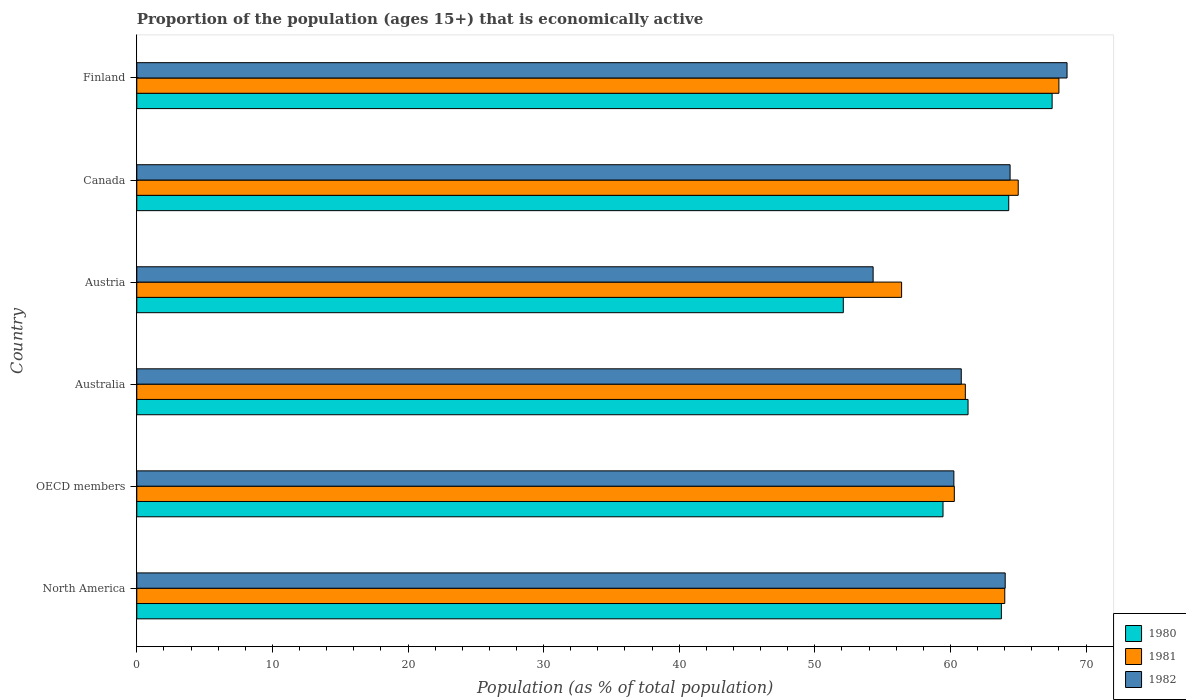How many bars are there on the 5th tick from the top?
Your answer should be compact. 3. What is the label of the 2nd group of bars from the top?
Provide a short and direct response. Canada. What is the proportion of the population that is economically active in 1982 in Canada?
Your response must be concise. 64.4. Across all countries, what is the maximum proportion of the population that is economically active in 1980?
Provide a succinct answer. 67.5. Across all countries, what is the minimum proportion of the population that is economically active in 1982?
Make the answer very short. 54.3. In which country was the proportion of the population that is economically active in 1982 maximum?
Provide a short and direct response. Finland. In which country was the proportion of the population that is economically active in 1980 minimum?
Offer a terse response. Austria. What is the total proportion of the population that is economically active in 1981 in the graph?
Make the answer very short. 374.79. What is the difference between the proportion of the population that is economically active in 1981 in Australia and that in Austria?
Offer a very short reply. 4.7. What is the difference between the proportion of the population that is economically active in 1980 in North America and the proportion of the population that is economically active in 1981 in OECD members?
Your response must be concise. 3.47. What is the average proportion of the population that is economically active in 1980 per country?
Your answer should be very brief. 61.4. What is the difference between the proportion of the population that is economically active in 1981 and proportion of the population that is economically active in 1982 in Canada?
Provide a short and direct response. 0.6. What is the ratio of the proportion of the population that is economically active in 1982 in Australia to that in Austria?
Provide a short and direct response. 1.12. Is the proportion of the population that is economically active in 1982 in Finland less than that in North America?
Ensure brevity in your answer.  No. Is the difference between the proportion of the population that is economically active in 1981 in Canada and Finland greater than the difference between the proportion of the population that is economically active in 1982 in Canada and Finland?
Your response must be concise. Yes. What is the difference between the highest and the second highest proportion of the population that is economically active in 1982?
Keep it short and to the point. 4.2. What is the difference between the highest and the lowest proportion of the population that is economically active in 1980?
Keep it short and to the point. 15.4. In how many countries, is the proportion of the population that is economically active in 1980 greater than the average proportion of the population that is economically active in 1980 taken over all countries?
Ensure brevity in your answer.  3. Is the sum of the proportion of the population that is economically active in 1981 in Australia and OECD members greater than the maximum proportion of the population that is economically active in 1980 across all countries?
Keep it short and to the point. Yes. What does the 3rd bar from the top in Australia represents?
Your answer should be compact. 1980. What does the 3rd bar from the bottom in Finland represents?
Provide a short and direct response. 1982. Is it the case that in every country, the sum of the proportion of the population that is economically active in 1982 and proportion of the population that is economically active in 1981 is greater than the proportion of the population that is economically active in 1980?
Your answer should be very brief. Yes. How many countries are there in the graph?
Keep it short and to the point. 6. What is the difference between two consecutive major ticks on the X-axis?
Your response must be concise. 10. Are the values on the major ticks of X-axis written in scientific E-notation?
Your response must be concise. No. Does the graph contain any zero values?
Ensure brevity in your answer.  No. Where does the legend appear in the graph?
Provide a succinct answer. Bottom right. What is the title of the graph?
Your answer should be compact. Proportion of the population (ages 15+) that is economically active. Does "1974" appear as one of the legend labels in the graph?
Your answer should be compact. No. What is the label or title of the X-axis?
Provide a succinct answer. Population (as % of total population). What is the Population (as % of total population) of 1980 in North America?
Your response must be concise. 63.76. What is the Population (as % of total population) in 1981 in North America?
Make the answer very short. 64.01. What is the Population (as % of total population) of 1982 in North America?
Provide a short and direct response. 64.04. What is the Population (as % of total population) of 1980 in OECD members?
Offer a very short reply. 59.45. What is the Population (as % of total population) in 1981 in OECD members?
Offer a terse response. 60.29. What is the Population (as % of total population) of 1982 in OECD members?
Ensure brevity in your answer.  60.25. What is the Population (as % of total population) of 1980 in Australia?
Keep it short and to the point. 61.3. What is the Population (as % of total population) in 1981 in Australia?
Your response must be concise. 61.1. What is the Population (as % of total population) of 1982 in Australia?
Offer a very short reply. 60.8. What is the Population (as % of total population) of 1980 in Austria?
Your answer should be compact. 52.1. What is the Population (as % of total population) of 1981 in Austria?
Give a very brief answer. 56.4. What is the Population (as % of total population) in 1982 in Austria?
Provide a succinct answer. 54.3. What is the Population (as % of total population) of 1980 in Canada?
Your answer should be compact. 64.3. What is the Population (as % of total population) of 1981 in Canada?
Your answer should be compact. 65. What is the Population (as % of total population) in 1982 in Canada?
Provide a succinct answer. 64.4. What is the Population (as % of total population) of 1980 in Finland?
Provide a short and direct response. 67.5. What is the Population (as % of total population) in 1981 in Finland?
Provide a succinct answer. 68. What is the Population (as % of total population) in 1982 in Finland?
Keep it short and to the point. 68.6. Across all countries, what is the maximum Population (as % of total population) of 1980?
Your answer should be very brief. 67.5. Across all countries, what is the maximum Population (as % of total population) of 1981?
Provide a short and direct response. 68. Across all countries, what is the maximum Population (as % of total population) of 1982?
Make the answer very short. 68.6. Across all countries, what is the minimum Population (as % of total population) of 1980?
Ensure brevity in your answer.  52.1. Across all countries, what is the minimum Population (as % of total population) in 1981?
Give a very brief answer. 56.4. Across all countries, what is the minimum Population (as % of total population) of 1982?
Ensure brevity in your answer.  54.3. What is the total Population (as % of total population) of 1980 in the graph?
Your answer should be very brief. 368.41. What is the total Population (as % of total population) in 1981 in the graph?
Give a very brief answer. 374.79. What is the total Population (as % of total population) in 1982 in the graph?
Your response must be concise. 372.39. What is the difference between the Population (as % of total population) of 1980 in North America and that in OECD members?
Provide a succinct answer. 4.3. What is the difference between the Population (as % of total population) of 1981 in North America and that in OECD members?
Your answer should be compact. 3.72. What is the difference between the Population (as % of total population) of 1982 in North America and that in OECD members?
Offer a very short reply. 3.78. What is the difference between the Population (as % of total population) of 1980 in North America and that in Australia?
Your answer should be very brief. 2.46. What is the difference between the Population (as % of total population) in 1981 in North America and that in Australia?
Your response must be concise. 2.91. What is the difference between the Population (as % of total population) of 1982 in North America and that in Australia?
Your answer should be compact. 3.24. What is the difference between the Population (as % of total population) in 1980 in North America and that in Austria?
Offer a very short reply. 11.66. What is the difference between the Population (as % of total population) of 1981 in North America and that in Austria?
Keep it short and to the point. 7.61. What is the difference between the Population (as % of total population) in 1982 in North America and that in Austria?
Offer a terse response. 9.74. What is the difference between the Population (as % of total population) of 1980 in North America and that in Canada?
Your response must be concise. -0.54. What is the difference between the Population (as % of total population) in 1981 in North America and that in Canada?
Your answer should be compact. -0.99. What is the difference between the Population (as % of total population) in 1982 in North America and that in Canada?
Your answer should be very brief. -0.36. What is the difference between the Population (as % of total population) in 1980 in North America and that in Finland?
Make the answer very short. -3.74. What is the difference between the Population (as % of total population) in 1981 in North America and that in Finland?
Your answer should be compact. -3.99. What is the difference between the Population (as % of total population) in 1982 in North America and that in Finland?
Keep it short and to the point. -4.56. What is the difference between the Population (as % of total population) of 1980 in OECD members and that in Australia?
Offer a terse response. -1.85. What is the difference between the Population (as % of total population) in 1981 in OECD members and that in Australia?
Make the answer very short. -0.81. What is the difference between the Population (as % of total population) of 1982 in OECD members and that in Australia?
Provide a succinct answer. -0.55. What is the difference between the Population (as % of total population) of 1980 in OECD members and that in Austria?
Offer a terse response. 7.35. What is the difference between the Population (as % of total population) in 1981 in OECD members and that in Austria?
Give a very brief answer. 3.89. What is the difference between the Population (as % of total population) of 1982 in OECD members and that in Austria?
Make the answer very short. 5.95. What is the difference between the Population (as % of total population) of 1980 in OECD members and that in Canada?
Offer a very short reply. -4.85. What is the difference between the Population (as % of total population) in 1981 in OECD members and that in Canada?
Give a very brief answer. -4.71. What is the difference between the Population (as % of total population) in 1982 in OECD members and that in Canada?
Provide a succinct answer. -4.15. What is the difference between the Population (as % of total population) in 1980 in OECD members and that in Finland?
Offer a very short reply. -8.05. What is the difference between the Population (as % of total population) in 1981 in OECD members and that in Finland?
Make the answer very short. -7.71. What is the difference between the Population (as % of total population) of 1982 in OECD members and that in Finland?
Provide a succinct answer. -8.35. What is the difference between the Population (as % of total population) of 1980 in Australia and that in Austria?
Provide a succinct answer. 9.2. What is the difference between the Population (as % of total population) in 1981 in Australia and that in Austria?
Offer a very short reply. 4.7. What is the difference between the Population (as % of total population) in 1982 in Australia and that in Austria?
Offer a very short reply. 6.5. What is the difference between the Population (as % of total population) in 1980 in Australia and that in Canada?
Your response must be concise. -3. What is the difference between the Population (as % of total population) in 1981 in Australia and that in Canada?
Make the answer very short. -3.9. What is the difference between the Population (as % of total population) in 1982 in Australia and that in Canada?
Your answer should be very brief. -3.6. What is the difference between the Population (as % of total population) in 1980 in Australia and that in Finland?
Keep it short and to the point. -6.2. What is the difference between the Population (as % of total population) of 1981 in Austria and that in Canada?
Your answer should be compact. -8.6. What is the difference between the Population (as % of total population) in 1982 in Austria and that in Canada?
Give a very brief answer. -10.1. What is the difference between the Population (as % of total population) of 1980 in Austria and that in Finland?
Offer a terse response. -15.4. What is the difference between the Population (as % of total population) in 1982 in Austria and that in Finland?
Give a very brief answer. -14.3. What is the difference between the Population (as % of total population) in 1981 in Canada and that in Finland?
Give a very brief answer. -3. What is the difference between the Population (as % of total population) of 1980 in North America and the Population (as % of total population) of 1981 in OECD members?
Keep it short and to the point. 3.47. What is the difference between the Population (as % of total population) of 1980 in North America and the Population (as % of total population) of 1982 in OECD members?
Offer a terse response. 3.5. What is the difference between the Population (as % of total population) of 1981 in North America and the Population (as % of total population) of 1982 in OECD members?
Your response must be concise. 3.75. What is the difference between the Population (as % of total population) of 1980 in North America and the Population (as % of total population) of 1981 in Australia?
Your answer should be compact. 2.66. What is the difference between the Population (as % of total population) in 1980 in North America and the Population (as % of total population) in 1982 in Australia?
Your answer should be compact. 2.96. What is the difference between the Population (as % of total population) in 1981 in North America and the Population (as % of total population) in 1982 in Australia?
Your response must be concise. 3.21. What is the difference between the Population (as % of total population) in 1980 in North America and the Population (as % of total population) in 1981 in Austria?
Ensure brevity in your answer.  7.36. What is the difference between the Population (as % of total population) of 1980 in North America and the Population (as % of total population) of 1982 in Austria?
Your answer should be very brief. 9.46. What is the difference between the Population (as % of total population) of 1981 in North America and the Population (as % of total population) of 1982 in Austria?
Your answer should be very brief. 9.71. What is the difference between the Population (as % of total population) in 1980 in North America and the Population (as % of total population) in 1981 in Canada?
Your answer should be very brief. -1.24. What is the difference between the Population (as % of total population) in 1980 in North America and the Population (as % of total population) in 1982 in Canada?
Give a very brief answer. -0.64. What is the difference between the Population (as % of total population) in 1981 in North America and the Population (as % of total population) in 1982 in Canada?
Your response must be concise. -0.39. What is the difference between the Population (as % of total population) of 1980 in North America and the Population (as % of total population) of 1981 in Finland?
Your answer should be compact. -4.24. What is the difference between the Population (as % of total population) in 1980 in North America and the Population (as % of total population) in 1982 in Finland?
Offer a terse response. -4.84. What is the difference between the Population (as % of total population) of 1981 in North America and the Population (as % of total population) of 1982 in Finland?
Ensure brevity in your answer.  -4.59. What is the difference between the Population (as % of total population) in 1980 in OECD members and the Population (as % of total population) in 1981 in Australia?
Make the answer very short. -1.65. What is the difference between the Population (as % of total population) of 1980 in OECD members and the Population (as % of total population) of 1982 in Australia?
Offer a very short reply. -1.35. What is the difference between the Population (as % of total population) of 1981 in OECD members and the Population (as % of total population) of 1982 in Australia?
Offer a very short reply. -0.51. What is the difference between the Population (as % of total population) of 1980 in OECD members and the Population (as % of total population) of 1981 in Austria?
Offer a terse response. 3.05. What is the difference between the Population (as % of total population) in 1980 in OECD members and the Population (as % of total population) in 1982 in Austria?
Provide a short and direct response. 5.15. What is the difference between the Population (as % of total population) in 1981 in OECD members and the Population (as % of total population) in 1982 in Austria?
Provide a short and direct response. 5.99. What is the difference between the Population (as % of total population) in 1980 in OECD members and the Population (as % of total population) in 1981 in Canada?
Make the answer very short. -5.55. What is the difference between the Population (as % of total population) of 1980 in OECD members and the Population (as % of total population) of 1982 in Canada?
Your answer should be very brief. -4.95. What is the difference between the Population (as % of total population) of 1981 in OECD members and the Population (as % of total population) of 1982 in Canada?
Your answer should be compact. -4.11. What is the difference between the Population (as % of total population) of 1980 in OECD members and the Population (as % of total population) of 1981 in Finland?
Your answer should be compact. -8.55. What is the difference between the Population (as % of total population) of 1980 in OECD members and the Population (as % of total population) of 1982 in Finland?
Make the answer very short. -9.15. What is the difference between the Population (as % of total population) in 1981 in OECD members and the Population (as % of total population) in 1982 in Finland?
Your answer should be compact. -8.31. What is the difference between the Population (as % of total population) of 1980 in Australia and the Population (as % of total population) of 1982 in Austria?
Make the answer very short. 7. What is the difference between the Population (as % of total population) of 1980 in Australia and the Population (as % of total population) of 1981 in Canada?
Give a very brief answer. -3.7. What is the difference between the Population (as % of total population) in 1981 in Australia and the Population (as % of total population) in 1982 in Canada?
Offer a very short reply. -3.3. What is the difference between the Population (as % of total population) of 1980 in Australia and the Population (as % of total population) of 1981 in Finland?
Ensure brevity in your answer.  -6.7. What is the difference between the Population (as % of total population) of 1980 in Australia and the Population (as % of total population) of 1982 in Finland?
Keep it short and to the point. -7.3. What is the difference between the Population (as % of total population) in 1980 in Austria and the Population (as % of total population) in 1982 in Canada?
Give a very brief answer. -12.3. What is the difference between the Population (as % of total population) in 1981 in Austria and the Population (as % of total population) in 1982 in Canada?
Offer a terse response. -8. What is the difference between the Population (as % of total population) of 1980 in Austria and the Population (as % of total population) of 1981 in Finland?
Offer a very short reply. -15.9. What is the difference between the Population (as % of total population) of 1980 in Austria and the Population (as % of total population) of 1982 in Finland?
Provide a succinct answer. -16.5. What is the difference between the Population (as % of total population) in 1981 in Austria and the Population (as % of total population) in 1982 in Finland?
Ensure brevity in your answer.  -12.2. What is the difference between the Population (as % of total population) in 1980 in Canada and the Population (as % of total population) in 1981 in Finland?
Your answer should be compact. -3.7. What is the difference between the Population (as % of total population) of 1980 in Canada and the Population (as % of total population) of 1982 in Finland?
Your response must be concise. -4.3. What is the difference between the Population (as % of total population) of 1981 in Canada and the Population (as % of total population) of 1982 in Finland?
Provide a succinct answer. -3.6. What is the average Population (as % of total population) in 1980 per country?
Make the answer very short. 61.4. What is the average Population (as % of total population) in 1981 per country?
Your answer should be very brief. 62.47. What is the average Population (as % of total population) of 1982 per country?
Ensure brevity in your answer.  62.07. What is the difference between the Population (as % of total population) of 1980 and Population (as % of total population) of 1981 in North America?
Ensure brevity in your answer.  -0.25. What is the difference between the Population (as % of total population) in 1980 and Population (as % of total population) in 1982 in North America?
Your answer should be compact. -0.28. What is the difference between the Population (as % of total population) of 1981 and Population (as % of total population) of 1982 in North America?
Provide a short and direct response. -0.03. What is the difference between the Population (as % of total population) of 1980 and Population (as % of total population) of 1981 in OECD members?
Provide a succinct answer. -0.83. What is the difference between the Population (as % of total population) in 1980 and Population (as % of total population) in 1982 in OECD members?
Offer a very short reply. -0.8. What is the difference between the Population (as % of total population) in 1981 and Population (as % of total population) in 1982 in OECD members?
Your response must be concise. 0.03. What is the difference between the Population (as % of total population) in 1980 and Population (as % of total population) in 1982 in Australia?
Make the answer very short. 0.5. What is the difference between the Population (as % of total population) in 1981 and Population (as % of total population) in 1982 in Austria?
Give a very brief answer. 2.1. What is the difference between the Population (as % of total population) of 1980 and Population (as % of total population) of 1981 in Canada?
Your response must be concise. -0.7. What is the difference between the Population (as % of total population) in 1980 and Population (as % of total population) in 1982 in Canada?
Offer a terse response. -0.1. What is the difference between the Population (as % of total population) in 1980 and Population (as % of total population) in 1981 in Finland?
Provide a short and direct response. -0.5. What is the difference between the Population (as % of total population) in 1981 and Population (as % of total population) in 1982 in Finland?
Give a very brief answer. -0.6. What is the ratio of the Population (as % of total population) of 1980 in North America to that in OECD members?
Offer a very short reply. 1.07. What is the ratio of the Population (as % of total population) in 1981 in North America to that in OECD members?
Give a very brief answer. 1.06. What is the ratio of the Population (as % of total population) of 1982 in North America to that in OECD members?
Provide a short and direct response. 1.06. What is the ratio of the Population (as % of total population) in 1980 in North America to that in Australia?
Your answer should be very brief. 1.04. What is the ratio of the Population (as % of total population) in 1981 in North America to that in Australia?
Offer a terse response. 1.05. What is the ratio of the Population (as % of total population) of 1982 in North America to that in Australia?
Provide a succinct answer. 1.05. What is the ratio of the Population (as % of total population) in 1980 in North America to that in Austria?
Your answer should be compact. 1.22. What is the ratio of the Population (as % of total population) in 1981 in North America to that in Austria?
Your answer should be very brief. 1.13. What is the ratio of the Population (as % of total population) of 1982 in North America to that in Austria?
Your answer should be compact. 1.18. What is the ratio of the Population (as % of total population) of 1980 in North America to that in Canada?
Give a very brief answer. 0.99. What is the ratio of the Population (as % of total population) in 1981 in North America to that in Canada?
Provide a short and direct response. 0.98. What is the ratio of the Population (as % of total population) of 1980 in North America to that in Finland?
Offer a terse response. 0.94. What is the ratio of the Population (as % of total population) of 1981 in North America to that in Finland?
Give a very brief answer. 0.94. What is the ratio of the Population (as % of total population) of 1982 in North America to that in Finland?
Provide a succinct answer. 0.93. What is the ratio of the Population (as % of total population) of 1980 in OECD members to that in Australia?
Offer a very short reply. 0.97. What is the ratio of the Population (as % of total population) of 1981 in OECD members to that in Australia?
Your answer should be very brief. 0.99. What is the ratio of the Population (as % of total population) in 1980 in OECD members to that in Austria?
Your answer should be compact. 1.14. What is the ratio of the Population (as % of total population) in 1981 in OECD members to that in Austria?
Make the answer very short. 1.07. What is the ratio of the Population (as % of total population) in 1982 in OECD members to that in Austria?
Keep it short and to the point. 1.11. What is the ratio of the Population (as % of total population) of 1980 in OECD members to that in Canada?
Your response must be concise. 0.92. What is the ratio of the Population (as % of total population) in 1981 in OECD members to that in Canada?
Your answer should be compact. 0.93. What is the ratio of the Population (as % of total population) in 1982 in OECD members to that in Canada?
Your response must be concise. 0.94. What is the ratio of the Population (as % of total population) in 1980 in OECD members to that in Finland?
Provide a succinct answer. 0.88. What is the ratio of the Population (as % of total population) of 1981 in OECD members to that in Finland?
Keep it short and to the point. 0.89. What is the ratio of the Population (as % of total population) in 1982 in OECD members to that in Finland?
Provide a succinct answer. 0.88. What is the ratio of the Population (as % of total population) of 1980 in Australia to that in Austria?
Provide a succinct answer. 1.18. What is the ratio of the Population (as % of total population) of 1982 in Australia to that in Austria?
Provide a short and direct response. 1.12. What is the ratio of the Population (as % of total population) in 1980 in Australia to that in Canada?
Ensure brevity in your answer.  0.95. What is the ratio of the Population (as % of total population) of 1982 in Australia to that in Canada?
Your answer should be very brief. 0.94. What is the ratio of the Population (as % of total population) in 1980 in Australia to that in Finland?
Keep it short and to the point. 0.91. What is the ratio of the Population (as % of total population) in 1981 in Australia to that in Finland?
Keep it short and to the point. 0.9. What is the ratio of the Population (as % of total population) in 1982 in Australia to that in Finland?
Provide a short and direct response. 0.89. What is the ratio of the Population (as % of total population) of 1980 in Austria to that in Canada?
Ensure brevity in your answer.  0.81. What is the ratio of the Population (as % of total population) of 1981 in Austria to that in Canada?
Your answer should be compact. 0.87. What is the ratio of the Population (as % of total population) of 1982 in Austria to that in Canada?
Your answer should be compact. 0.84. What is the ratio of the Population (as % of total population) in 1980 in Austria to that in Finland?
Provide a short and direct response. 0.77. What is the ratio of the Population (as % of total population) in 1981 in Austria to that in Finland?
Ensure brevity in your answer.  0.83. What is the ratio of the Population (as % of total population) in 1982 in Austria to that in Finland?
Give a very brief answer. 0.79. What is the ratio of the Population (as % of total population) in 1980 in Canada to that in Finland?
Offer a terse response. 0.95. What is the ratio of the Population (as % of total population) in 1981 in Canada to that in Finland?
Your answer should be compact. 0.96. What is the ratio of the Population (as % of total population) in 1982 in Canada to that in Finland?
Make the answer very short. 0.94. What is the difference between the highest and the second highest Population (as % of total population) of 1980?
Provide a short and direct response. 3.2. What is the difference between the highest and the second highest Population (as % of total population) of 1982?
Give a very brief answer. 4.2. What is the difference between the highest and the lowest Population (as % of total population) of 1980?
Provide a succinct answer. 15.4. What is the difference between the highest and the lowest Population (as % of total population) of 1982?
Make the answer very short. 14.3. 